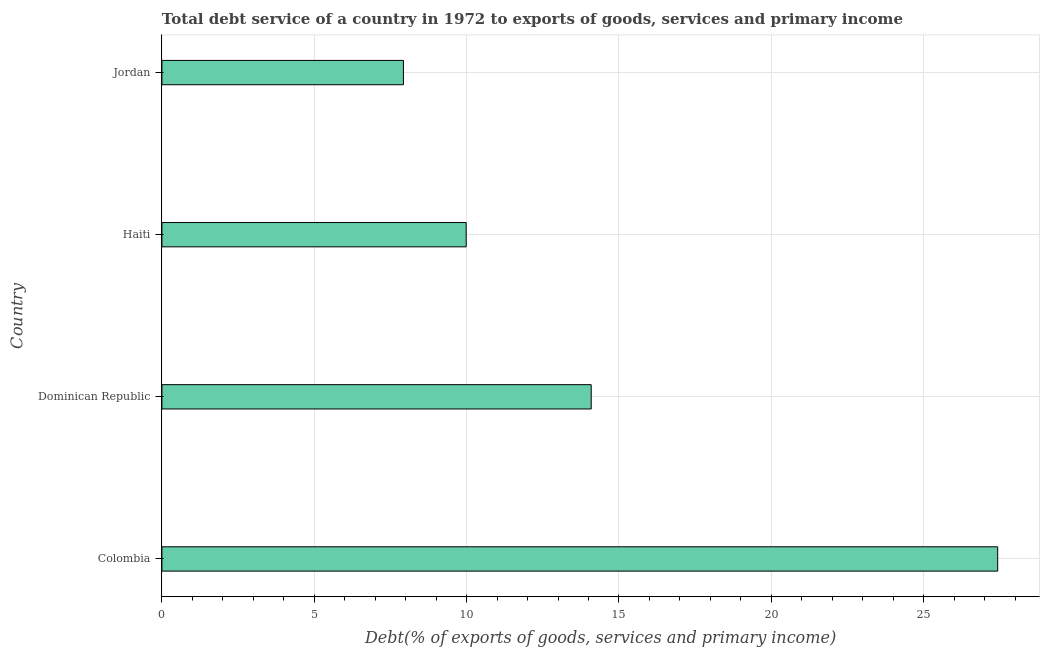What is the title of the graph?
Offer a very short reply. Total debt service of a country in 1972 to exports of goods, services and primary income. What is the label or title of the X-axis?
Provide a succinct answer. Debt(% of exports of goods, services and primary income). What is the total debt service in Jordan?
Your answer should be very brief. 7.93. Across all countries, what is the maximum total debt service?
Provide a short and direct response. 27.43. Across all countries, what is the minimum total debt service?
Ensure brevity in your answer.  7.93. In which country was the total debt service maximum?
Provide a succinct answer. Colombia. In which country was the total debt service minimum?
Your response must be concise. Jordan. What is the sum of the total debt service?
Offer a very short reply. 59.43. What is the difference between the total debt service in Colombia and Haiti?
Keep it short and to the point. 17.44. What is the average total debt service per country?
Give a very brief answer. 14.86. What is the median total debt service?
Provide a succinct answer. 12.04. What is the ratio of the total debt service in Colombia to that in Haiti?
Your answer should be compact. 2.75. What is the difference between the highest and the second highest total debt service?
Provide a succinct answer. 13.34. What is the difference between the highest and the lowest total debt service?
Offer a very short reply. 19.5. How many bars are there?
Ensure brevity in your answer.  4. Are all the bars in the graph horizontal?
Offer a terse response. Yes. What is the difference between two consecutive major ticks on the X-axis?
Offer a very short reply. 5. Are the values on the major ticks of X-axis written in scientific E-notation?
Give a very brief answer. No. What is the Debt(% of exports of goods, services and primary income) in Colombia?
Your answer should be compact. 27.43. What is the Debt(% of exports of goods, services and primary income) in Dominican Republic?
Give a very brief answer. 14.09. What is the Debt(% of exports of goods, services and primary income) in Haiti?
Make the answer very short. 9.99. What is the Debt(% of exports of goods, services and primary income) in Jordan?
Your answer should be compact. 7.93. What is the difference between the Debt(% of exports of goods, services and primary income) in Colombia and Dominican Republic?
Ensure brevity in your answer.  13.34. What is the difference between the Debt(% of exports of goods, services and primary income) in Colombia and Haiti?
Keep it short and to the point. 17.44. What is the difference between the Debt(% of exports of goods, services and primary income) in Colombia and Jordan?
Provide a succinct answer. 19.5. What is the difference between the Debt(% of exports of goods, services and primary income) in Dominican Republic and Haiti?
Your answer should be very brief. 4.1. What is the difference between the Debt(% of exports of goods, services and primary income) in Dominican Republic and Jordan?
Your answer should be compact. 6.16. What is the difference between the Debt(% of exports of goods, services and primary income) in Haiti and Jordan?
Ensure brevity in your answer.  2.06. What is the ratio of the Debt(% of exports of goods, services and primary income) in Colombia to that in Dominican Republic?
Keep it short and to the point. 1.95. What is the ratio of the Debt(% of exports of goods, services and primary income) in Colombia to that in Haiti?
Your response must be concise. 2.75. What is the ratio of the Debt(% of exports of goods, services and primary income) in Colombia to that in Jordan?
Your answer should be very brief. 3.46. What is the ratio of the Debt(% of exports of goods, services and primary income) in Dominican Republic to that in Haiti?
Your response must be concise. 1.41. What is the ratio of the Debt(% of exports of goods, services and primary income) in Dominican Republic to that in Jordan?
Give a very brief answer. 1.78. What is the ratio of the Debt(% of exports of goods, services and primary income) in Haiti to that in Jordan?
Make the answer very short. 1.26. 